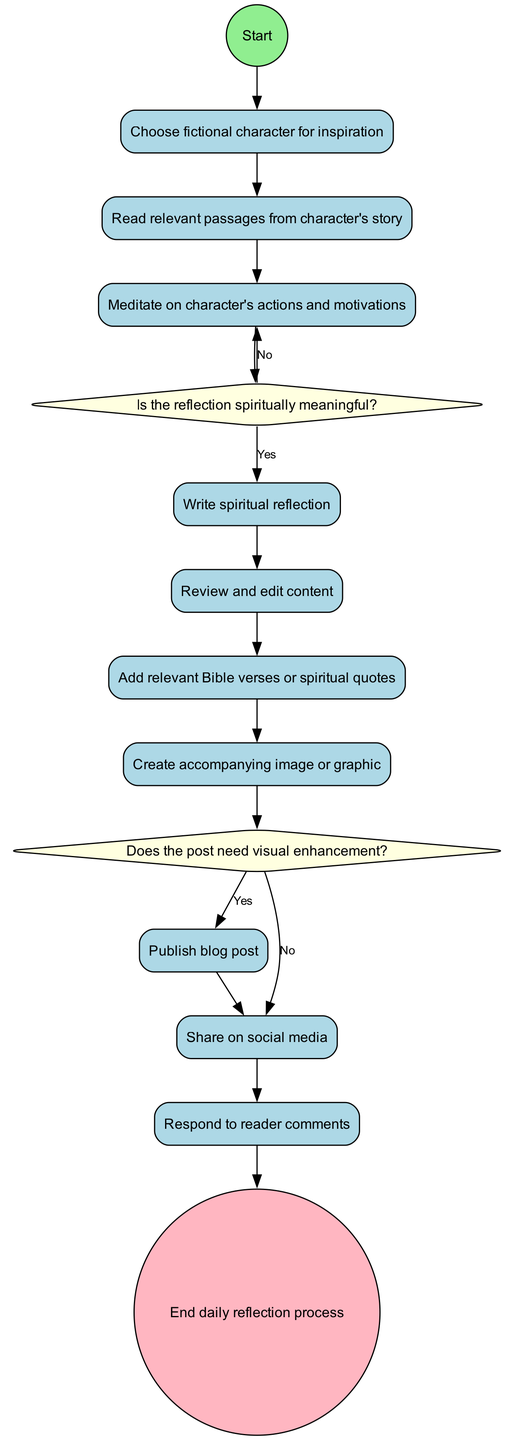What is the first activity in the diagram? The diagram starts with the "Start" node, which leads to the first activity, "Choose fictional character for inspiration."
Answer: Choose fictional character for inspiration How many decision points are in the diagram? The diagram has two decision points: the first one regarding the spiritual meaningfulness of the reflection and the second about the need for visual enhancement.
Answer: 2 What is the last activity before the end node? Before reaching the end node, the last activity is "Share on social media," which follows the activity of publishing the blog post.
Answer: Share on social media What happens if the reflection is not spiritually meaningful? If the reflection is not spiritually meaningful, the flow returns to "Meditate on character's actions and motivations," suggesting further contemplation before proceeding.
Answer: Meditate on character's actions and motivations What decision follows after creating an accompanying image or graphic? After creating an accompanying image or graphic, the diagram presents the decision point about whether the post needs visual enhancement.
Answer: Does the post need visual enhancement? What activity comes directly after writing a spiritual reflection? After writing a spiritual reflection, the next activity is to review and edit content before proceeding to additional steps.
Answer: Review and edit content What is the relationship between "Add relevant Bible verses or spiritual quotes" and the decision point? The activity "Add relevant Bible verses or spiritual quotes" is directly linked to the decision point that assesses if the post needs visual enhancement, indicating that it occurs prior to that decision.
Answer: Create accompanying image or graphic Which activity requires meditation on the character's actions and motivations the most? The decision point concerning the spiritual meaningfulness of the reflection leads back to this activity if the reflection is deemed not meaningful, indicating its importance in the process.
Answer: Meditate on character's actions and motivations 